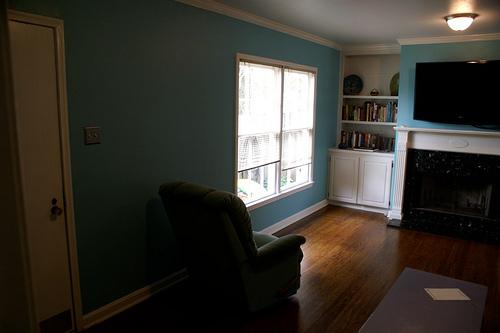Is this in color or black and white?
Write a very short answer. Color. What kind of seating is in the room?
Be succinct. Recliner. Is there a curtain on the window?
Be succinct. No. Is the sofa facing toward the bookshelf?
Answer briefly. Yes. Does the chair match the rest of the room?
Give a very brief answer. No. Is anyone sitting on the armchair?
Answer briefly. No. What color is the wall?
Short answer required. Blue. 